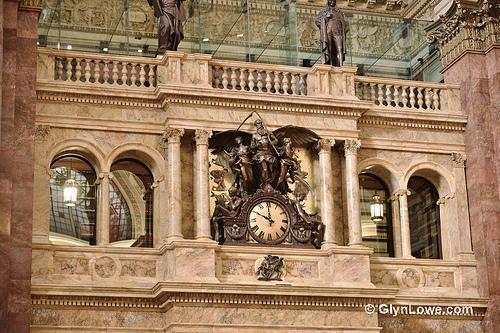How many statues are there?
Give a very brief answer. 2. 